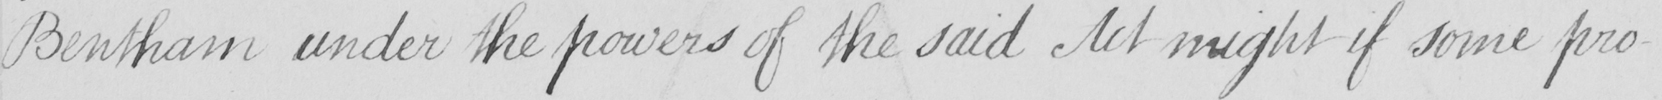What is written in this line of handwriting? Bentham under the powers of the said Act might if some pro- 